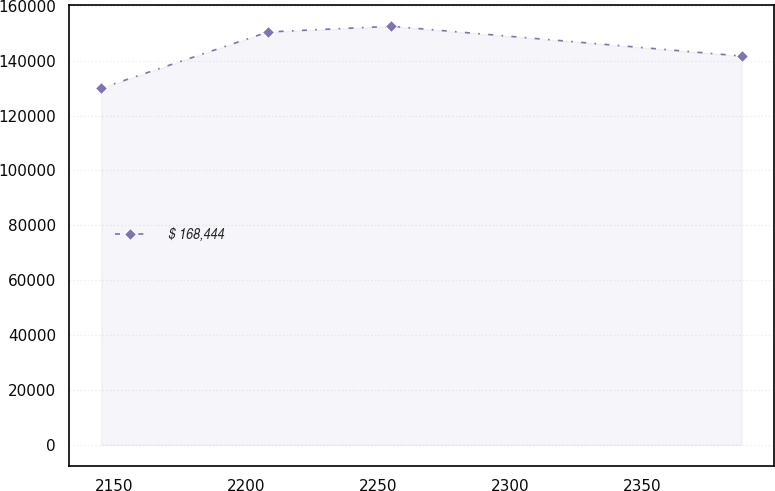Convert chart to OTSL. <chart><loc_0><loc_0><loc_500><loc_500><line_chart><ecel><fcel>$ 168,444<nl><fcel>2145.09<fcel>129990<nl><fcel>2208.29<fcel>150463<nl><fcel>2255.12<fcel>152549<nl><fcel>2387.83<fcel>141694<nl></chart> 